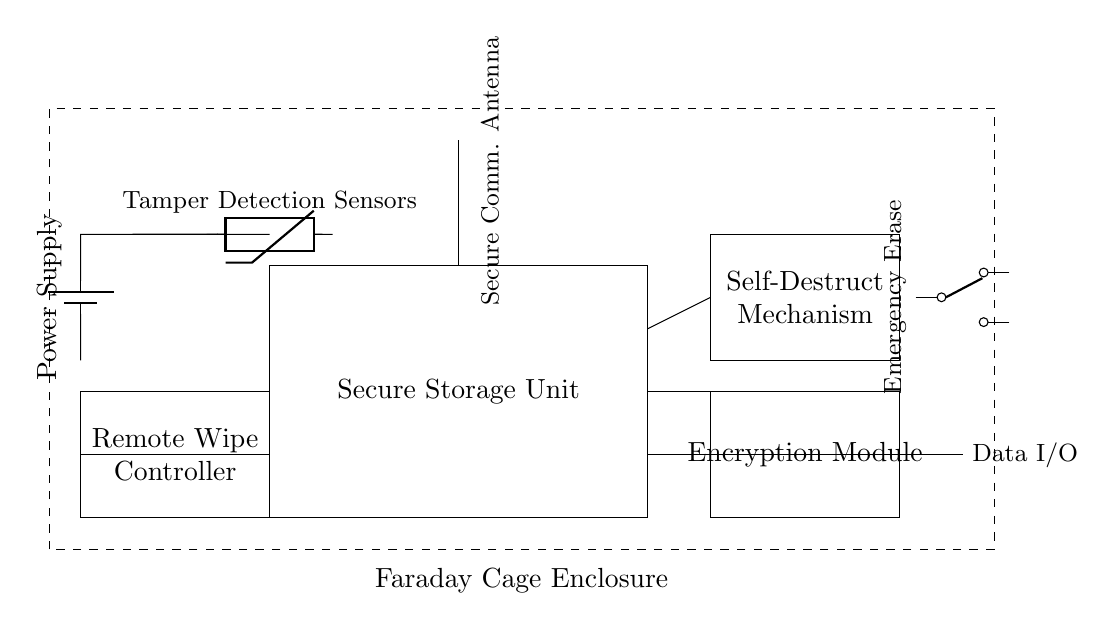What component connects the encryption module to the secure storage unit? The connection is a direct line, indicating physical integration between the encryption module and the secure storage unit. These connections allow the encryption module to process data as it is stored in the secure storage unit.
Answer: direct line What feature does the self-destruct mechanism provide? The self-destruct mechanism is designed to permanently erase data to protect sensitive information in case of unauthorized access. This enhances security by ensuring that any tampering attempt leads to data destruction.
Answer: permanent data erase How is the remote wipe controller powered? The remote wipe controller obtains power from the battery shown in the diagram. The battery connects directly to the controller, providing the necessary energy for its operation.
Answer: battery What do the tamper detection sensors do? The tamper detection sensors monitor unauthorized access and trigger security protocols if tampering is detected, ensuring data protection. This makes it a critical component for enhancing security in the device.
Answer: monitor tampering What layout shape represents the Faraday cage enclosure? The Faraday cage enclosure is represented by a dashed rectangle. This layout symbolizes the protective shield that guards against external electronic interference and signals.
Answer: dashed rectangle What does the emergency erase button do? The emergency erase button allows for immediate data destruction, providing a manual override to erase data instantly during a security breach or emergency. This feature is crucial for protecting classified information.
Answer: immediate data destruction 